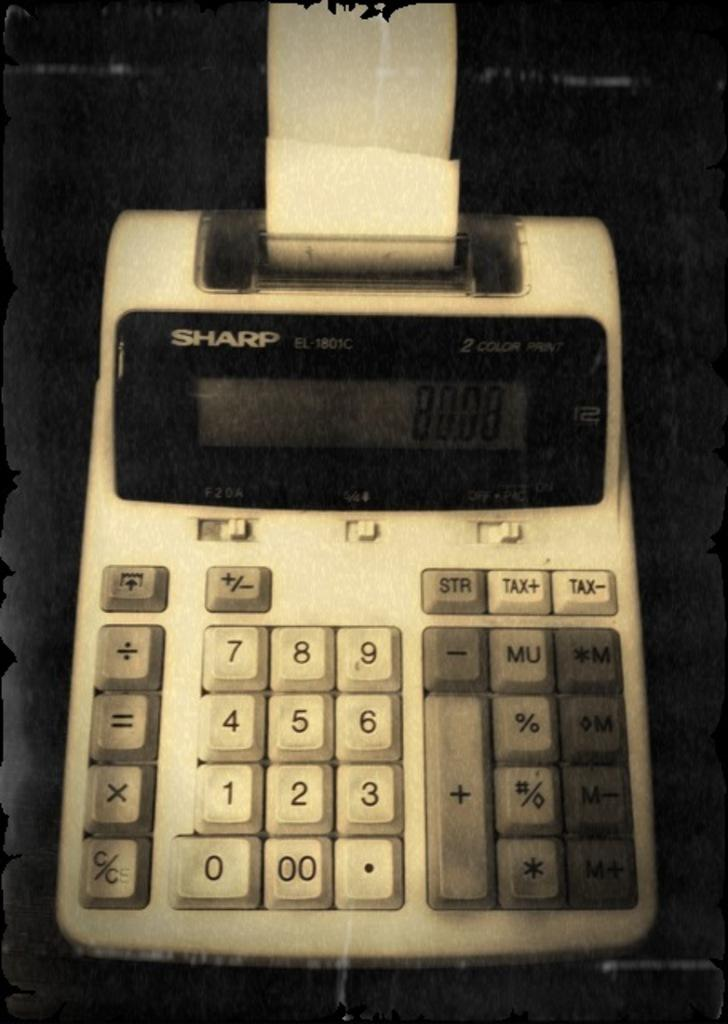<image>
Summarize the visual content of the image. a Sharp calculating device with many numbers on it 